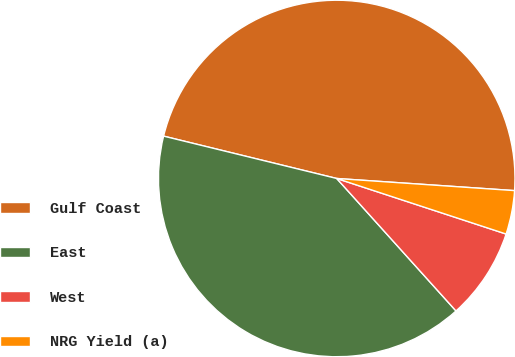Convert chart to OTSL. <chart><loc_0><loc_0><loc_500><loc_500><pie_chart><fcel>Gulf Coast<fcel>East<fcel>West<fcel>NRG Yield (a)<nl><fcel>47.27%<fcel>40.49%<fcel>8.29%<fcel>3.96%<nl></chart> 